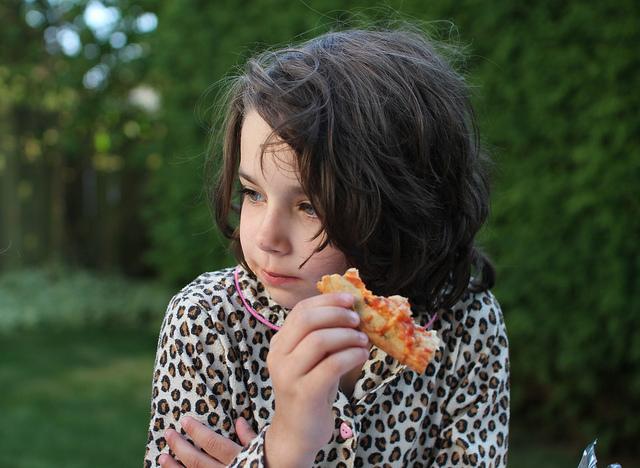What color is the little heart button?
Short answer required. Pink. What is the pattern of the girl's top?
Write a very short answer. Leopard. What food is the girl eating?
Short answer required. Pizza. 